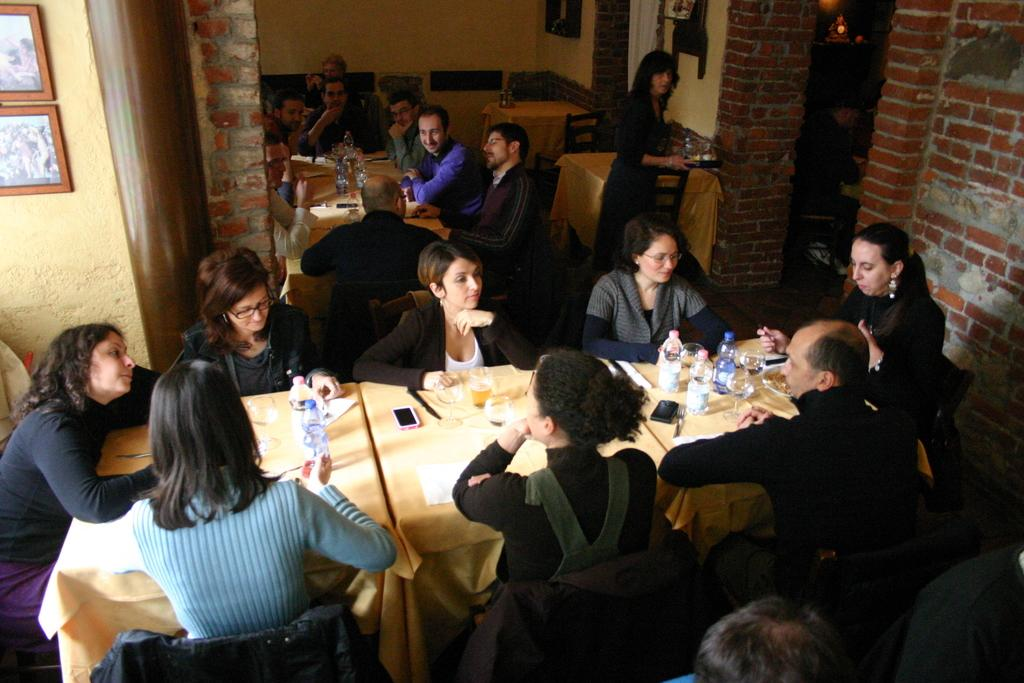How many people are in the image? There is a group of people in the image. What are the people doing in the image? The people are sitting in front of a table. What can be seen on the table in the image? There is a mobile, a glass, and bottles on the table. What is attached to the wall in the image? There are frames attached to the wall. What type of brass instrument is being played by the sheep in the image? There are no brass instruments or sheep present in the image. 